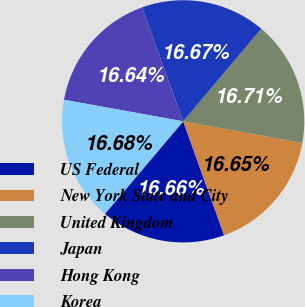<chart> <loc_0><loc_0><loc_500><loc_500><pie_chart><fcel>US Federal<fcel>New York State and City<fcel>United Kingdom<fcel>Japan<fcel>Hong Kong<fcel>Korea<nl><fcel>16.66%<fcel>16.65%<fcel>16.71%<fcel>16.67%<fcel>16.64%<fcel>16.68%<nl></chart> 